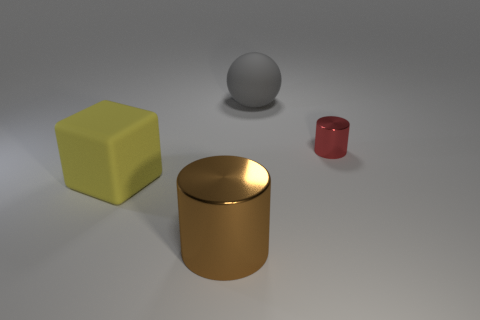Add 1 tiny green rubber objects. How many objects exist? 5 Subtract all large red matte cylinders. Subtract all large yellow matte blocks. How many objects are left? 3 Add 2 yellow rubber things. How many yellow rubber things are left? 3 Add 1 gray cylinders. How many gray cylinders exist? 1 Subtract all brown cylinders. How many cylinders are left? 1 Subtract 0 cyan cylinders. How many objects are left? 4 Subtract all balls. How many objects are left? 3 Subtract 1 cylinders. How many cylinders are left? 1 Subtract all brown cylinders. Subtract all red balls. How many cylinders are left? 1 Subtract all red spheres. How many brown cylinders are left? 1 